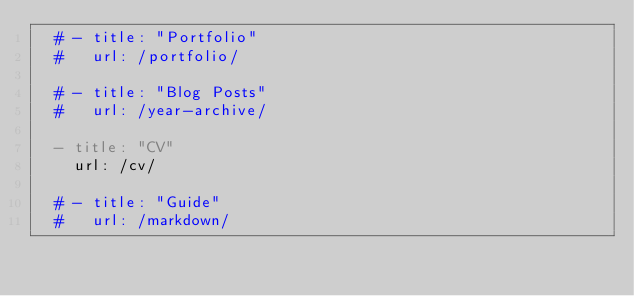Convert code to text. <code><loc_0><loc_0><loc_500><loc_500><_YAML_>  # - title: "Portfolio"
  #   url: /portfolio/
        
  # - title: "Blog Posts"
  #   url: /year-archive/
    
  - title: "CV"
    url: /cv/
    
  # - title: "Guide"
  #   url: /markdown/
</code> 